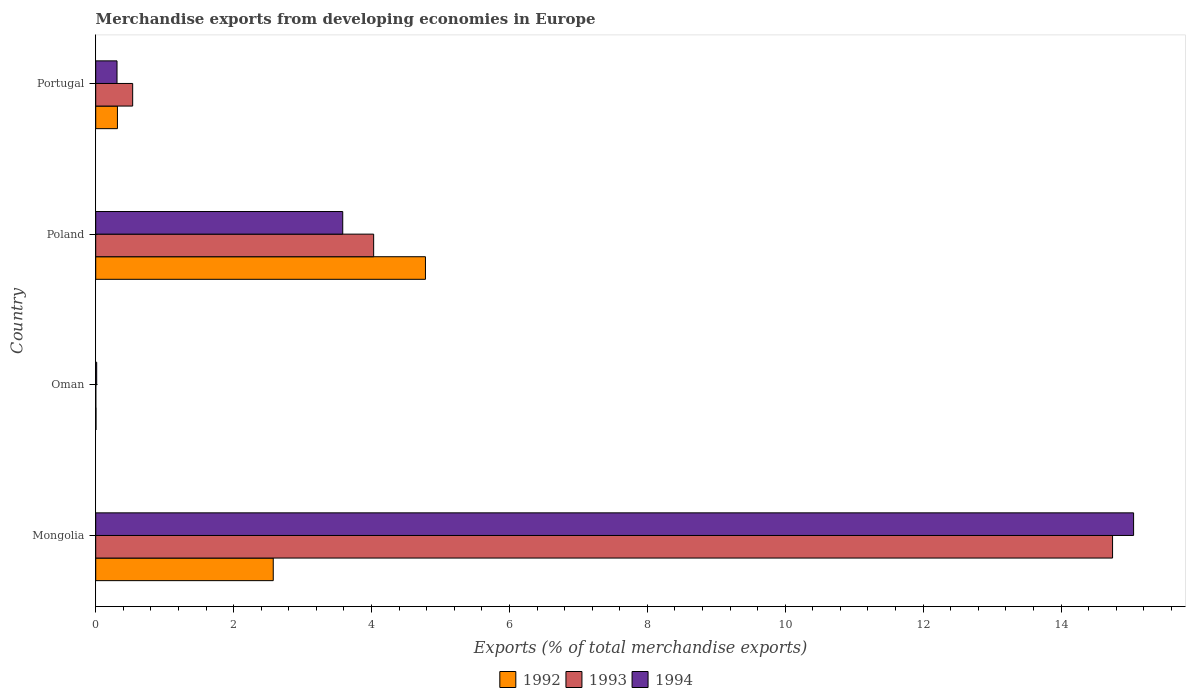How many different coloured bars are there?
Your answer should be compact. 3. Are the number of bars per tick equal to the number of legend labels?
Offer a very short reply. Yes. How many bars are there on the 3rd tick from the top?
Your response must be concise. 3. How many bars are there on the 1st tick from the bottom?
Your answer should be very brief. 3. What is the percentage of total merchandise exports in 1993 in Portugal?
Provide a succinct answer. 0.54. Across all countries, what is the maximum percentage of total merchandise exports in 1992?
Your answer should be compact. 4.78. Across all countries, what is the minimum percentage of total merchandise exports in 1994?
Offer a terse response. 0.01. In which country was the percentage of total merchandise exports in 1992 maximum?
Your response must be concise. Poland. In which country was the percentage of total merchandise exports in 1994 minimum?
Ensure brevity in your answer.  Oman. What is the total percentage of total merchandise exports in 1992 in the graph?
Offer a terse response. 7.68. What is the difference between the percentage of total merchandise exports in 1993 in Oman and that in Poland?
Offer a very short reply. -4.03. What is the difference between the percentage of total merchandise exports in 1994 in Mongolia and the percentage of total merchandise exports in 1993 in Oman?
Ensure brevity in your answer.  15.05. What is the average percentage of total merchandise exports in 1992 per country?
Offer a terse response. 1.92. What is the difference between the percentage of total merchandise exports in 1992 and percentage of total merchandise exports in 1994 in Portugal?
Your response must be concise. 0.01. In how many countries, is the percentage of total merchandise exports in 1993 greater than 2 %?
Provide a succinct answer. 2. What is the ratio of the percentage of total merchandise exports in 1993 in Mongolia to that in Oman?
Your answer should be compact. 9923.6. Is the percentage of total merchandise exports in 1993 in Oman less than that in Poland?
Keep it short and to the point. Yes. What is the difference between the highest and the second highest percentage of total merchandise exports in 1994?
Ensure brevity in your answer.  11.47. What is the difference between the highest and the lowest percentage of total merchandise exports in 1992?
Offer a very short reply. 4.78. What does the 1st bar from the bottom in Portugal represents?
Your answer should be compact. 1992. How many bars are there?
Provide a succinct answer. 12. Are all the bars in the graph horizontal?
Keep it short and to the point. Yes. How many countries are there in the graph?
Give a very brief answer. 4. What is the difference between two consecutive major ticks on the X-axis?
Your answer should be very brief. 2. Are the values on the major ticks of X-axis written in scientific E-notation?
Your answer should be very brief. No. Where does the legend appear in the graph?
Make the answer very short. Bottom center. How many legend labels are there?
Make the answer very short. 3. How are the legend labels stacked?
Keep it short and to the point. Horizontal. What is the title of the graph?
Give a very brief answer. Merchandise exports from developing economies in Europe. What is the label or title of the X-axis?
Your answer should be very brief. Exports (% of total merchandise exports). What is the Exports (% of total merchandise exports) in 1992 in Mongolia?
Make the answer very short. 2.57. What is the Exports (% of total merchandise exports) in 1993 in Mongolia?
Provide a short and direct response. 14.75. What is the Exports (% of total merchandise exports) of 1994 in Mongolia?
Make the answer very short. 15.05. What is the Exports (% of total merchandise exports) of 1992 in Oman?
Keep it short and to the point. 0. What is the Exports (% of total merchandise exports) in 1993 in Oman?
Offer a very short reply. 0. What is the Exports (% of total merchandise exports) in 1994 in Oman?
Your answer should be very brief. 0.01. What is the Exports (% of total merchandise exports) in 1992 in Poland?
Give a very brief answer. 4.78. What is the Exports (% of total merchandise exports) of 1993 in Poland?
Your response must be concise. 4.03. What is the Exports (% of total merchandise exports) of 1994 in Poland?
Give a very brief answer. 3.58. What is the Exports (% of total merchandise exports) of 1992 in Portugal?
Keep it short and to the point. 0.32. What is the Exports (% of total merchandise exports) of 1993 in Portugal?
Make the answer very short. 0.54. What is the Exports (% of total merchandise exports) of 1994 in Portugal?
Provide a succinct answer. 0.31. Across all countries, what is the maximum Exports (% of total merchandise exports) of 1992?
Make the answer very short. 4.78. Across all countries, what is the maximum Exports (% of total merchandise exports) in 1993?
Ensure brevity in your answer.  14.75. Across all countries, what is the maximum Exports (% of total merchandise exports) of 1994?
Ensure brevity in your answer.  15.05. Across all countries, what is the minimum Exports (% of total merchandise exports) in 1992?
Make the answer very short. 0. Across all countries, what is the minimum Exports (% of total merchandise exports) of 1993?
Keep it short and to the point. 0. Across all countries, what is the minimum Exports (% of total merchandise exports) in 1994?
Keep it short and to the point. 0.01. What is the total Exports (% of total merchandise exports) in 1992 in the graph?
Keep it short and to the point. 7.68. What is the total Exports (% of total merchandise exports) of 1993 in the graph?
Your response must be concise. 19.32. What is the total Exports (% of total merchandise exports) in 1994 in the graph?
Give a very brief answer. 18.96. What is the difference between the Exports (% of total merchandise exports) of 1992 in Mongolia and that in Oman?
Offer a terse response. 2.57. What is the difference between the Exports (% of total merchandise exports) in 1993 in Mongolia and that in Oman?
Offer a terse response. 14.75. What is the difference between the Exports (% of total merchandise exports) of 1994 in Mongolia and that in Oman?
Your answer should be compact. 15.04. What is the difference between the Exports (% of total merchandise exports) of 1992 in Mongolia and that in Poland?
Your answer should be compact. -2.21. What is the difference between the Exports (% of total merchandise exports) of 1993 in Mongolia and that in Poland?
Make the answer very short. 10.72. What is the difference between the Exports (% of total merchandise exports) of 1994 in Mongolia and that in Poland?
Give a very brief answer. 11.47. What is the difference between the Exports (% of total merchandise exports) in 1992 in Mongolia and that in Portugal?
Provide a short and direct response. 2.26. What is the difference between the Exports (% of total merchandise exports) in 1993 in Mongolia and that in Portugal?
Your answer should be compact. 14.21. What is the difference between the Exports (% of total merchandise exports) in 1994 in Mongolia and that in Portugal?
Offer a very short reply. 14.74. What is the difference between the Exports (% of total merchandise exports) in 1992 in Oman and that in Poland?
Offer a terse response. -4.78. What is the difference between the Exports (% of total merchandise exports) in 1993 in Oman and that in Poland?
Provide a succinct answer. -4.03. What is the difference between the Exports (% of total merchandise exports) in 1994 in Oman and that in Poland?
Ensure brevity in your answer.  -3.57. What is the difference between the Exports (% of total merchandise exports) of 1992 in Oman and that in Portugal?
Ensure brevity in your answer.  -0.31. What is the difference between the Exports (% of total merchandise exports) of 1993 in Oman and that in Portugal?
Offer a terse response. -0.53. What is the difference between the Exports (% of total merchandise exports) in 1994 in Oman and that in Portugal?
Give a very brief answer. -0.29. What is the difference between the Exports (% of total merchandise exports) in 1992 in Poland and that in Portugal?
Make the answer very short. 4.47. What is the difference between the Exports (% of total merchandise exports) in 1993 in Poland and that in Portugal?
Provide a short and direct response. 3.49. What is the difference between the Exports (% of total merchandise exports) of 1994 in Poland and that in Portugal?
Give a very brief answer. 3.27. What is the difference between the Exports (% of total merchandise exports) in 1992 in Mongolia and the Exports (% of total merchandise exports) in 1993 in Oman?
Provide a succinct answer. 2.57. What is the difference between the Exports (% of total merchandise exports) of 1992 in Mongolia and the Exports (% of total merchandise exports) of 1994 in Oman?
Offer a terse response. 2.56. What is the difference between the Exports (% of total merchandise exports) in 1993 in Mongolia and the Exports (% of total merchandise exports) in 1994 in Oman?
Give a very brief answer. 14.73. What is the difference between the Exports (% of total merchandise exports) in 1992 in Mongolia and the Exports (% of total merchandise exports) in 1993 in Poland?
Make the answer very short. -1.46. What is the difference between the Exports (% of total merchandise exports) in 1992 in Mongolia and the Exports (% of total merchandise exports) in 1994 in Poland?
Provide a short and direct response. -1.01. What is the difference between the Exports (% of total merchandise exports) in 1993 in Mongolia and the Exports (% of total merchandise exports) in 1994 in Poland?
Your answer should be very brief. 11.16. What is the difference between the Exports (% of total merchandise exports) of 1992 in Mongolia and the Exports (% of total merchandise exports) of 1993 in Portugal?
Provide a succinct answer. 2.04. What is the difference between the Exports (% of total merchandise exports) in 1992 in Mongolia and the Exports (% of total merchandise exports) in 1994 in Portugal?
Your response must be concise. 2.27. What is the difference between the Exports (% of total merchandise exports) in 1993 in Mongolia and the Exports (% of total merchandise exports) in 1994 in Portugal?
Provide a succinct answer. 14.44. What is the difference between the Exports (% of total merchandise exports) in 1992 in Oman and the Exports (% of total merchandise exports) in 1993 in Poland?
Your answer should be very brief. -4.03. What is the difference between the Exports (% of total merchandise exports) of 1992 in Oman and the Exports (% of total merchandise exports) of 1994 in Poland?
Keep it short and to the point. -3.58. What is the difference between the Exports (% of total merchandise exports) in 1993 in Oman and the Exports (% of total merchandise exports) in 1994 in Poland?
Offer a very short reply. -3.58. What is the difference between the Exports (% of total merchandise exports) of 1992 in Oman and the Exports (% of total merchandise exports) of 1993 in Portugal?
Offer a very short reply. -0.53. What is the difference between the Exports (% of total merchandise exports) of 1992 in Oman and the Exports (% of total merchandise exports) of 1994 in Portugal?
Provide a succinct answer. -0.3. What is the difference between the Exports (% of total merchandise exports) in 1993 in Oman and the Exports (% of total merchandise exports) in 1994 in Portugal?
Offer a very short reply. -0.31. What is the difference between the Exports (% of total merchandise exports) in 1992 in Poland and the Exports (% of total merchandise exports) in 1993 in Portugal?
Make the answer very short. 4.25. What is the difference between the Exports (% of total merchandise exports) in 1992 in Poland and the Exports (% of total merchandise exports) in 1994 in Portugal?
Keep it short and to the point. 4.47. What is the difference between the Exports (% of total merchandise exports) in 1993 in Poland and the Exports (% of total merchandise exports) in 1994 in Portugal?
Provide a short and direct response. 3.72. What is the average Exports (% of total merchandise exports) of 1992 per country?
Your answer should be compact. 1.92. What is the average Exports (% of total merchandise exports) in 1993 per country?
Make the answer very short. 4.83. What is the average Exports (% of total merchandise exports) in 1994 per country?
Provide a short and direct response. 4.74. What is the difference between the Exports (% of total merchandise exports) in 1992 and Exports (% of total merchandise exports) in 1993 in Mongolia?
Make the answer very short. -12.17. What is the difference between the Exports (% of total merchandise exports) in 1992 and Exports (% of total merchandise exports) in 1994 in Mongolia?
Provide a short and direct response. -12.48. What is the difference between the Exports (% of total merchandise exports) in 1993 and Exports (% of total merchandise exports) in 1994 in Mongolia?
Ensure brevity in your answer.  -0.31. What is the difference between the Exports (% of total merchandise exports) in 1992 and Exports (% of total merchandise exports) in 1993 in Oman?
Offer a terse response. 0. What is the difference between the Exports (% of total merchandise exports) of 1992 and Exports (% of total merchandise exports) of 1994 in Oman?
Offer a terse response. -0.01. What is the difference between the Exports (% of total merchandise exports) in 1993 and Exports (% of total merchandise exports) in 1994 in Oman?
Your answer should be very brief. -0.01. What is the difference between the Exports (% of total merchandise exports) in 1992 and Exports (% of total merchandise exports) in 1993 in Poland?
Offer a terse response. 0.75. What is the difference between the Exports (% of total merchandise exports) in 1992 and Exports (% of total merchandise exports) in 1994 in Poland?
Provide a succinct answer. 1.2. What is the difference between the Exports (% of total merchandise exports) of 1993 and Exports (% of total merchandise exports) of 1994 in Poland?
Make the answer very short. 0.45. What is the difference between the Exports (% of total merchandise exports) of 1992 and Exports (% of total merchandise exports) of 1993 in Portugal?
Offer a terse response. -0.22. What is the difference between the Exports (% of total merchandise exports) of 1992 and Exports (% of total merchandise exports) of 1994 in Portugal?
Provide a short and direct response. 0.01. What is the difference between the Exports (% of total merchandise exports) of 1993 and Exports (% of total merchandise exports) of 1994 in Portugal?
Offer a terse response. 0.23. What is the ratio of the Exports (% of total merchandise exports) of 1992 in Mongolia to that in Oman?
Provide a succinct answer. 615.69. What is the ratio of the Exports (% of total merchandise exports) of 1993 in Mongolia to that in Oman?
Your answer should be compact. 9923.6. What is the ratio of the Exports (% of total merchandise exports) in 1994 in Mongolia to that in Oman?
Provide a succinct answer. 1055.93. What is the ratio of the Exports (% of total merchandise exports) of 1992 in Mongolia to that in Poland?
Make the answer very short. 0.54. What is the ratio of the Exports (% of total merchandise exports) of 1993 in Mongolia to that in Poland?
Keep it short and to the point. 3.66. What is the ratio of the Exports (% of total merchandise exports) of 1994 in Mongolia to that in Poland?
Keep it short and to the point. 4.2. What is the ratio of the Exports (% of total merchandise exports) of 1992 in Mongolia to that in Portugal?
Offer a very short reply. 8.17. What is the ratio of the Exports (% of total merchandise exports) of 1993 in Mongolia to that in Portugal?
Provide a succinct answer. 27.51. What is the ratio of the Exports (% of total merchandise exports) of 1994 in Mongolia to that in Portugal?
Offer a terse response. 48.71. What is the ratio of the Exports (% of total merchandise exports) of 1992 in Oman to that in Poland?
Give a very brief answer. 0. What is the ratio of the Exports (% of total merchandise exports) of 1993 in Oman to that in Poland?
Your answer should be compact. 0. What is the ratio of the Exports (% of total merchandise exports) in 1994 in Oman to that in Poland?
Ensure brevity in your answer.  0. What is the ratio of the Exports (% of total merchandise exports) of 1992 in Oman to that in Portugal?
Make the answer very short. 0.01. What is the ratio of the Exports (% of total merchandise exports) in 1993 in Oman to that in Portugal?
Your response must be concise. 0. What is the ratio of the Exports (% of total merchandise exports) in 1994 in Oman to that in Portugal?
Your answer should be compact. 0.05. What is the ratio of the Exports (% of total merchandise exports) of 1992 in Poland to that in Portugal?
Your answer should be compact. 15.18. What is the ratio of the Exports (% of total merchandise exports) in 1993 in Poland to that in Portugal?
Offer a terse response. 7.52. What is the ratio of the Exports (% of total merchandise exports) of 1994 in Poland to that in Portugal?
Keep it short and to the point. 11.59. What is the difference between the highest and the second highest Exports (% of total merchandise exports) of 1992?
Your answer should be very brief. 2.21. What is the difference between the highest and the second highest Exports (% of total merchandise exports) in 1993?
Offer a terse response. 10.72. What is the difference between the highest and the second highest Exports (% of total merchandise exports) in 1994?
Ensure brevity in your answer.  11.47. What is the difference between the highest and the lowest Exports (% of total merchandise exports) in 1992?
Provide a short and direct response. 4.78. What is the difference between the highest and the lowest Exports (% of total merchandise exports) in 1993?
Make the answer very short. 14.75. What is the difference between the highest and the lowest Exports (% of total merchandise exports) of 1994?
Your answer should be compact. 15.04. 